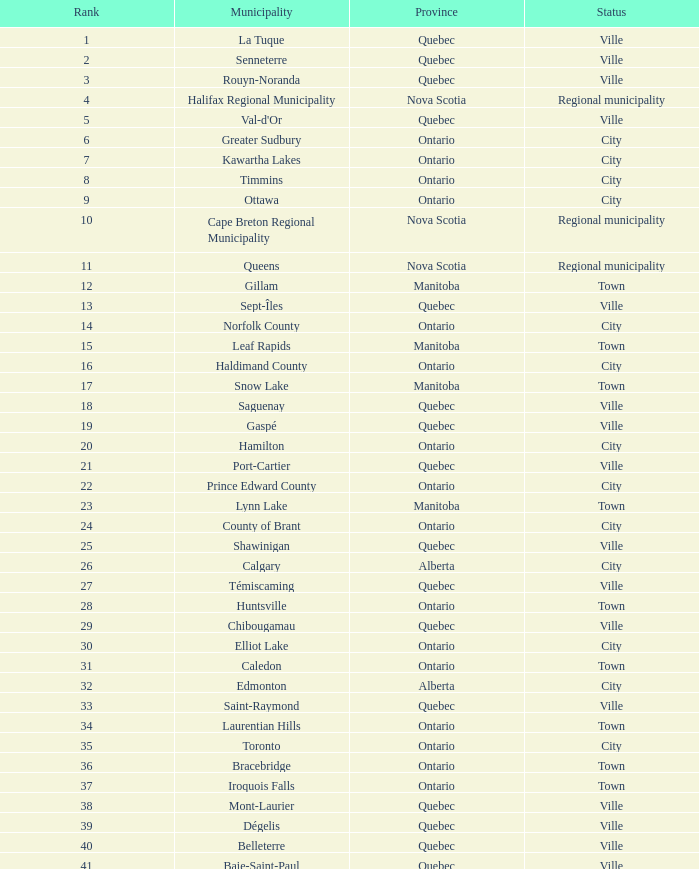14? 22.0. I'm looking to parse the entire table for insights. Could you assist me with that? {'header': ['Rank', 'Municipality', 'Province', 'Status'], 'rows': [['1', 'La Tuque', 'Quebec', 'Ville'], ['2', 'Senneterre', 'Quebec', 'Ville'], ['3', 'Rouyn-Noranda', 'Quebec', 'Ville'], ['4', 'Halifax Regional Municipality', 'Nova Scotia', 'Regional municipality'], ['5', "Val-d'Or", 'Quebec', 'Ville'], ['6', 'Greater Sudbury', 'Ontario', 'City'], ['7', 'Kawartha Lakes', 'Ontario', 'City'], ['8', 'Timmins', 'Ontario', 'City'], ['9', 'Ottawa', 'Ontario', 'City'], ['10', 'Cape Breton Regional Municipality', 'Nova Scotia', 'Regional municipality'], ['11', 'Queens', 'Nova Scotia', 'Regional municipality'], ['12', 'Gillam', 'Manitoba', 'Town'], ['13', 'Sept-Îles', 'Quebec', 'Ville'], ['14', 'Norfolk County', 'Ontario', 'City'], ['15', 'Leaf Rapids', 'Manitoba', 'Town'], ['16', 'Haldimand County', 'Ontario', 'City'], ['17', 'Snow Lake', 'Manitoba', 'Town'], ['18', 'Saguenay', 'Quebec', 'Ville'], ['19', 'Gaspé', 'Quebec', 'Ville'], ['20', 'Hamilton', 'Ontario', 'City'], ['21', 'Port-Cartier', 'Quebec', 'Ville'], ['22', 'Prince Edward County', 'Ontario', 'City'], ['23', 'Lynn Lake', 'Manitoba', 'Town'], ['24', 'County of Brant', 'Ontario', 'City'], ['25', 'Shawinigan', 'Quebec', 'Ville'], ['26', 'Calgary', 'Alberta', 'City'], ['27', 'Témiscaming', 'Quebec', 'Ville'], ['28', 'Huntsville', 'Ontario', 'Town'], ['29', 'Chibougamau', 'Quebec', 'Ville'], ['30', 'Elliot Lake', 'Ontario', 'City'], ['31', 'Caledon', 'Ontario', 'Town'], ['32', 'Edmonton', 'Alberta', 'City'], ['33', 'Saint-Raymond', 'Quebec', 'Ville'], ['34', 'Laurentian Hills', 'Ontario', 'Town'], ['35', 'Toronto', 'Ontario', 'City'], ['36', 'Bracebridge', 'Ontario', 'Town'], ['37', 'Iroquois Falls', 'Ontario', 'Town'], ['38', 'Mont-Laurier', 'Quebec', 'Ville'], ['39', 'Dégelis', 'Quebec', 'Ville'], ['40', 'Belleterre', 'Quebec', 'Ville'], ['41', 'Baie-Saint-Paul', 'Quebec', 'Ville'], ['42', 'Cochrane', 'Ontario', 'Town'], ['43', 'South Bruce Peninsula', 'Ontario', 'Town'], ['44', 'Lakeshore', 'Ontario', 'Town'], ['45', 'Kearney', 'Ontario', 'Town'], ['46', 'Blind River', 'Ontario', 'Town'], ['47', 'Gravenhurst', 'Ontario', 'Town'], ['48', 'Mississippi Mills', 'Ontario', 'Town'], ['49', 'Northeastern Manitoulin and the Islands', 'Ontario', 'Town'], ['50', 'Quinte West', 'Ontario', 'City'], ['51', 'Mirabel', 'Quebec', 'Ville'], ['52', 'Fermont', 'Quebec', 'Ville'], ['53', 'Winnipeg', 'Manitoba', 'City'], ['54', 'Greater Napanee', 'Ontario', 'Town'], ['55', 'La Malbaie', 'Quebec', 'Ville'], ['56', 'Rivière-Rouge', 'Quebec', 'Ville'], ['57', 'Québec City', 'Quebec', 'Ville'], ['58', 'Kingston', 'Ontario', 'City'], ['59', 'Lévis', 'Quebec', 'Ville'], ['60', "St. John's", 'Newfoundland and Labrador', 'City'], ['61', 'Bécancour', 'Quebec', 'Ville'], ['62', 'Percé', 'Quebec', 'Ville'], ['63', 'Amos', 'Quebec', 'Ville'], ['64', 'London', 'Ontario', 'City'], ['65', 'Chandler', 'Quebec', 'Ville'], ['66', 'Whitehorse', 'Yukon', 'City'], ['67', 'Gracefield', 'Quebec', 'Ville'], ['68', 'Baie Verte', 'Newfoundland and Labrador', 'Town'], ['69', 'Milton', 'Ontario', 'Town'], ['70', 'Montreal', 'Quebec', 'Ville'], ['71', 'Saint-Félicien', 'Quebec', 'Ville'], ['72', 'Abbotsford', 'British Columbia', 'City'], ['73', 'Sherbrooke', 'Quebec', 'Ville'], ['74', 'Gatineau', 'Quebec', 'Ville'], ['75', 'Pohénégamook', 'Quebec', 'Ville'], ['76', 'Baie-Comeau', 'Quebec', 'Ville'], ['77', 'Thunder Bay', 'Ontario', 'City'], ['78', 'Plympton–Wyoming', 'Ontario', 'Town'], ['79', 'Surrey', 'British Columbia', 'City'], ['80', 'Prince George', 'British Columbia', 'City'], ['81', 'Saint John', 'New Brunswick', 'City'], ['82', 'North Bay', 'Ontario', 'City'], ['83', 'Happy Valley-Goose Bay', 'Newfoundland and Labrador', 'Town'], ['84', 'Minto', 'Ontario', 'Town'], ['85', 'Kamloops', 'British Columbia', 'City'], ['86', 'Erin', 'Ontario', 'Town'], ['87', 'Clarence-Rockland', 'Ontario', 'City'], ['88', 'Cookshire-Eaton', 'Quebec', 'Ville'], ['89', 'Dolbeau-Mistassini', 'Quebec', 'Ville'], ['90', 'Trois-Rivières', 'Quebec', 'Ville'], ['91', 'Mississauga', 'Ontario', 'City'], ['92', 'Georgina', 'Ontario', 'Town'], ['93', 'The Blue Mountains', 'Ontario', 'Town'], ['94', 'Innisfil', 'Ontario', 'Town'], ['95', 'Essex', 'Ontario', 'Town'], ['96', 'Mono', 'Ontario', 'Town'], ['97', 'Halton Hills', 'Ontario', 'Town'], ['98', 'New Tecumseth', 'Ontario', 'Town'], ['99', 'Vaughan', 'Ontario', 'City'], ['100', 'Brampton', 'Ontario', 'City']]} 